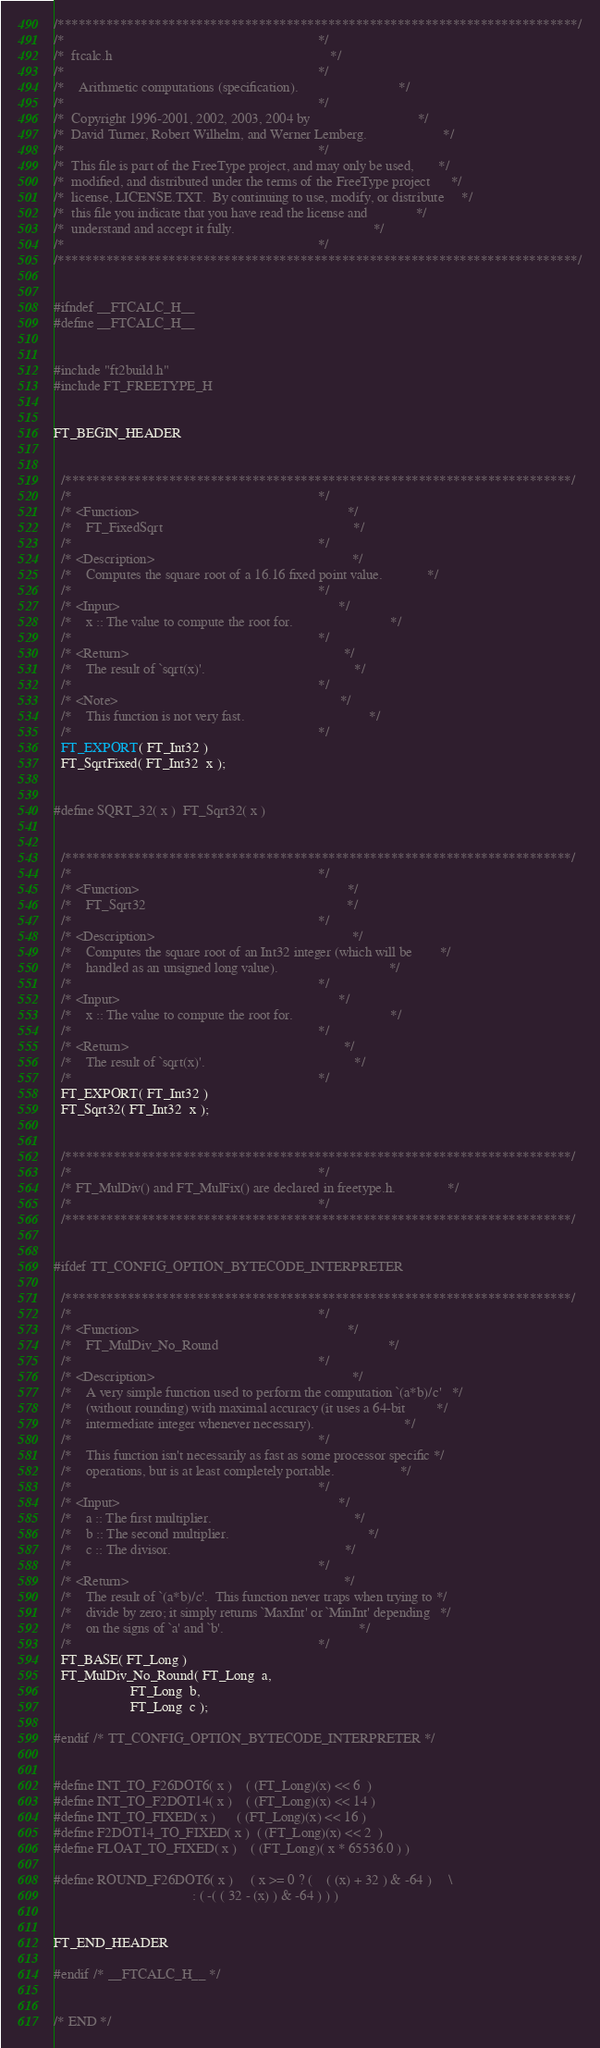<code> <loc_0><loc_0><loc_500><loc_500><_C_>/***************************************************************************/
/*                                                                         */
/*  ftcalc.h                                                               */
/*                                                                         */
/*    Arithmetic computations (specification).                             */
/*                                                                         */
/*  Copyright 1996-2001, 2002, 2003, 2004 by                               */
/*  David Turner, Robert Wilhelm, and Werner Lemberg.                      */
/*                                                                         */
/*  This file is part of the FreeType project, and may only be used,       */
/*  modified, and distributed under the terms of the FreeType project      */
/*  license, LICENSE.TXT.  By continuing to use, modify, or distribute     */
/*  this file you indicate that you have read the license and              */
/*  understand and accept it fully.                                        */
/*                                                                         */
/***************************************************************************/


#ifndef __FTCALC_H__
#define __FTCALC_H__


#include "ft2build.h"
#include FT_FREETYPE_H


FT_BEGIN_HEADER


  /*************************************************************************/
  /*                                                                       */
  /* <Function>                                                            */
  /*    FT_FixedSqrt                                                       */
  /*                                                                       */
  /* <Description>                                                         */
  /*    Computes the square root of a 16.16 fixed point value.             */
  /*                                                                       */
  /* <Input>                                                               */
  /*    x :: The value to compute the root for.                            */
  /*                                                                       */
  /* <Return>                                                              */
  /*    The result of `sqrt(x)'.                                           */
  /*                                                                       */
  /* <Note>                                                                */
  /*    This function is not very fast.                                    */
  /*                                                                       */
  FT_EXPORT( FT_Int32 )
  FT_SqrtFixed( FT_Int32  x );


#define SQRT_32( x )  FT_Sqrt32( x )


  /*************************************************************************/
  /*                                                                       */
  /* <Function>                                                            */
  /*    FT_Sqrt32                                                          */
  /*                                                                       */
  /* <Description>                                                         */
  /*    Computes the square root of an Int32 integer (which will be        */
  /*    handled as an unsigned long value).                                */
  /*                                                                       */
  /* <Input>                                                               */
  /*    x :: The value to compute the root for.                            */
  /*                                                                       */
  /* <Return>                                                              */
  /*    The result of `sqrt(x)'.                                           */
  /*                                                                       */
  FT_EXPORT( FT_Int32 )
  FT_Sqrt32( FT_Int32  x );


  /*************************************************************************/
  /*                                                                       */
  /* FT_MulDiv() and FT_MulFix() are declared in freetype.h.               */
  /*                                                                       */
  /*************************************************************************/


#ifdef TT_CONFIG_OPTION_BYTECODE_INTERPRETER

  /*************************************************************************/
  /*                                                                       */
  /* <Function>                                                            */
  /*    FT_MulDiv_No_Round                                                 */
  /*                                                                       */
  /* <Description>                                                         */
  /*    A very simple function used to perform the computation `(a*b)/c'   */
  /*    (without rounding) with maximal accuracy (it uses a 64-bit         */
  /*    intermediate integer whenever necessary).                          */
  /*                                                                       */
  /*    This function isn't necessarily as fast as some processor specific */
  /*    operations, but is at least completely portable.                   */
  /*                                                                       */
  /* <Input>                                                               */
  /*    a :: The first multiplier.                                         */
  /*    b :: The second multiplier.                                        */
  /*    c :: The divisor.                                                  */
  /*                                                                       */
  /* <Return>                                                              */
  /*    The result of `(a*b)/c'.  This function never traps when trying to */
  /*    divide by zero; it simply returns `MaxInt' or `MinInt' depending   */
  /*    on the signs of `a' and `b'.                                       */
  /*                                                                       */
  FT_BASE( FT_Long )
  FT_MulDiv_No_Round( FT_Long  a,
                      FT_Long  b,
                      FT_Long  c );

#endif /* TT_CONFIG_OPTION_BYTECODE_INTERPRETER */


#define INT_TO_F26DOT6( x )    ( (FT_Long)(x) << 6  )
#define INT_TO_F2DOT14( x )    ( (FT_Long)(x) << 14 )
#define INT_TO_FIXED( x )      ( (FT_Long)(x) << 16 )
#define F2DOT14_TO_FIXED( x )  ( (FT_Long)(x) << 2  )
#define FLOAT_TO_FIXED( x )    ( (FT_Long)( x * 65536.0 ) )

#define ROUND_F26DOT6( x )     ( x >= 0 ? (    ( (x) + 32 ) & -64 )     \
                                        : ( -( ( 32 - (x) ) & -64 ) ) )


FT_END_HEADER

#endif /* __FTCALC_H__ */


/* END */
</code> 